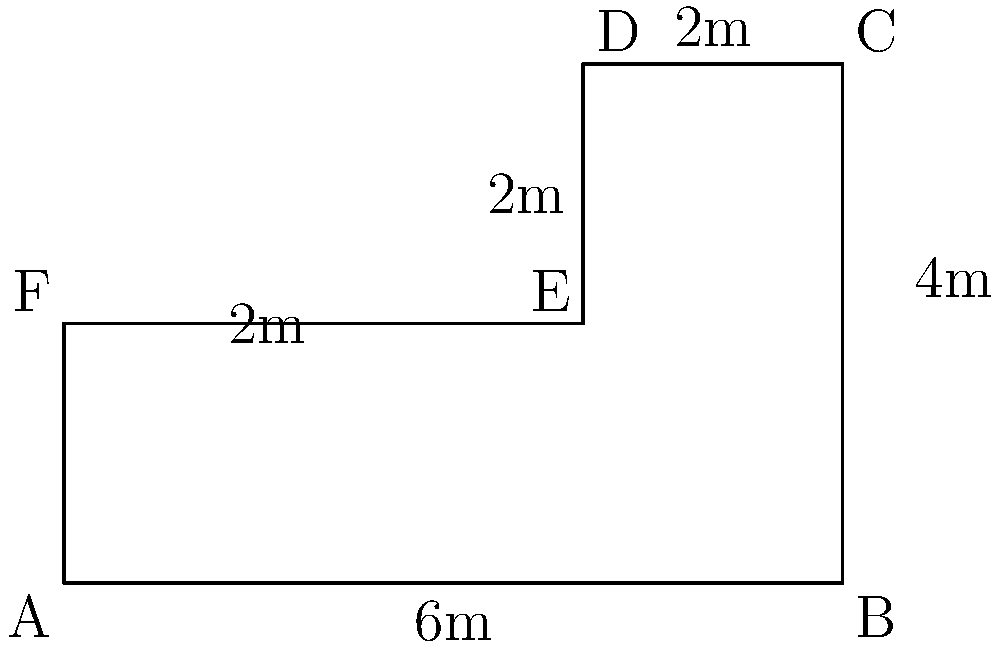A new trading floor layout is being designed for a financial firm. The floor plan is represented by the composite shape shown above. Calculate the total area of the trading floor in square meters. To calculate the area of this composite shape, we can divide it into two rectangles and add their areas:

1. Rectangle 1 (larger rectangle):
   Length = 6m
   Width = 2m
   Area of Rectangle 1 = $6m \times 2m = 12m^2$

2. Rectangle 2 (smaller rectangle on top):
   Length = 4m
   Width = 2m
   Area of Rectangle 2 = $4m \times 2m = 8m^2$

3. Total area:
   Total Area = Area of Rectangle 1 + Area of Rectangle 2
               = $12m^2 + 8m^2 = 20m^2$

Therefore, the total area of the trading floor is 20 square meters.
Answer: $20m^2$ 